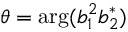Convert formula to latex. <formula><loc_0><loc_0><loc_500><loc_500>\theta = \arg ( b _ { 1 } ^ { 2 } b _ { 2 } ^ { * } )</formula> 